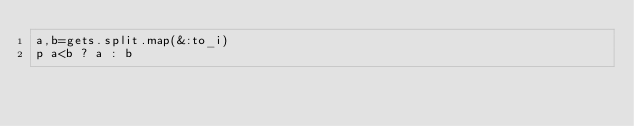<code> <loc_0><loc_0><loc_500><loc_500><_Ruby_>a,b=gets.split.map(&:to_i)
p a<b ? a : b</code> 